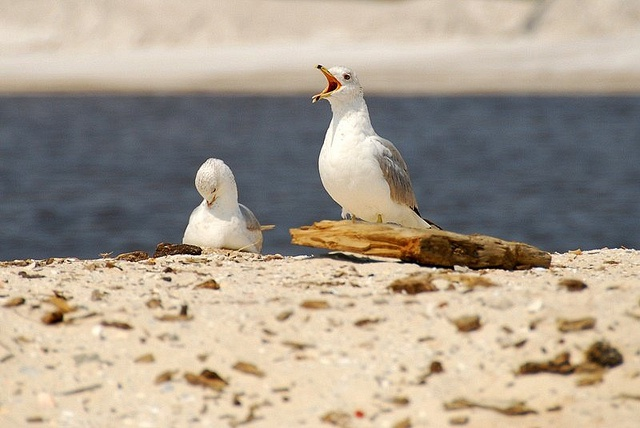Describe the objects in this image and their specific colors. I can see bird in tan, ivory, and darkgray tones and bird in tan, ivory, and darkgray tones in this image. 